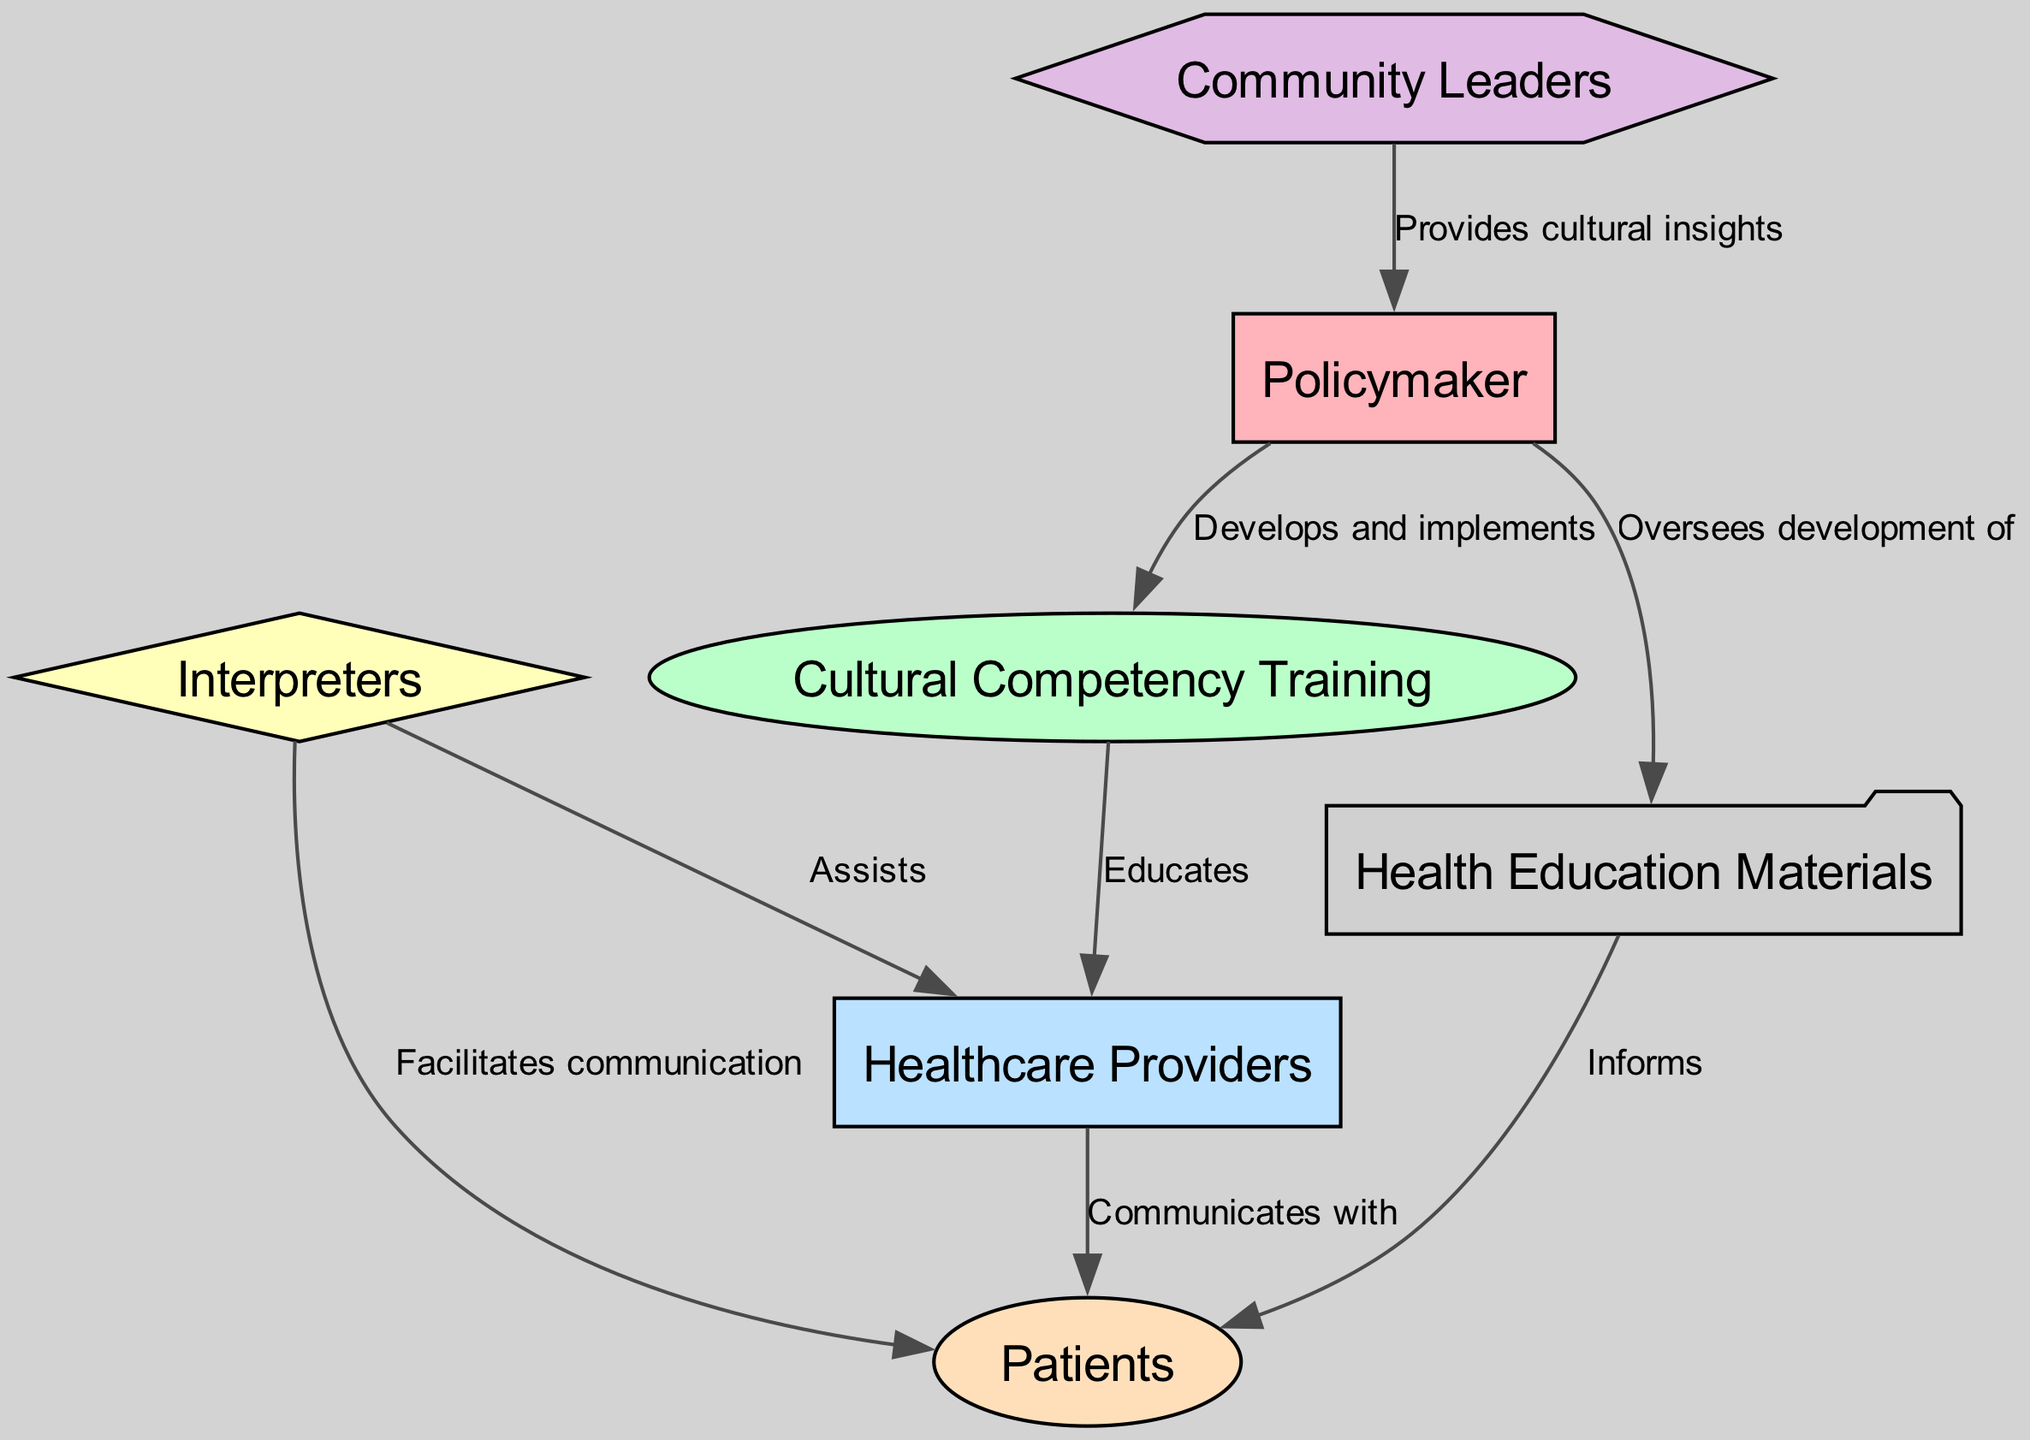What is the number of nodes in the diagram? The diagram includes the following nodes: Policymaker, Cultural Competency Training, Healthcare Providers, Interpreters, Patients, Community Leaders, and Health Education Materials. Counting these gives a total of seven nodes.
Answer: 7 Who educates the healthcare providers? The edge labeled "Educates" points from Cultural Competency Training to Healthcare Providers, indicating that Cultural Competency Training is responsible for educating them.
Answer: Cultural Competency Training What role do interpreters have in communicating with patients? There is an edge labeled "Facilitates communication" from Interpreters to Patients, which shows that the role of interpreters is to facilitate communication between healthcare providers and patients.
Answer: Facilitates communication How many edges are present in the diagram? The diagram lists the following edges: Develops and implements, Educates, Communicates with, Assists, Facilitates communication, Provides cultural insights, Oversees development of, and Informs. Counting these gives a total of eight edges.
Answer: 8 Which node is responsible for developing cultural competency training? The edge labeled "Develops and implements" connects Policymaker to Cultural Competency Training, indicating that the Policymaker is responsible for this action.
Answer: Policymaker What do health education materials inform? The edge labeled "Informs" from Health Education Materials to Patients indicates that these materials are meant to inform patients about relevant health information.
Answer: Patients Which nodes are linked directly to the Policymaker? The Policymaker node has edges leading to Cultural Competency Training, Health Education Materials, and receives insights from Community Leaders, establishing a direct connection to these three nodes.
Answer: Cultural Competency Training, Health Education Materials, Community Leaders Which role assists healthcare providers? The edge connecting Interpreters to Healthcare Providers with the label "Assists" indicates that it is the Interpreters who provide assistance to healthcare providers.
Answer: Interpreters What two nodes have direct communication with patients? The nodes that directly communicate with Patients are Healthcare Providers (shown by "Communicates with") and Interpreters (indicated by "Facilitates communication"). These two roles are essential for ensuring effective communication with patients.
Answer: Healthcare Providers, Interpreters 